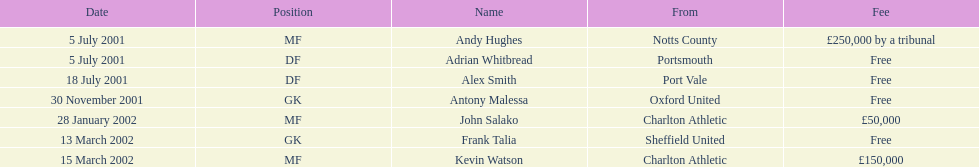Which individuals underwent a transfer following november 30, 2001? John Salako, Frank Talia, Kevin Watson. 